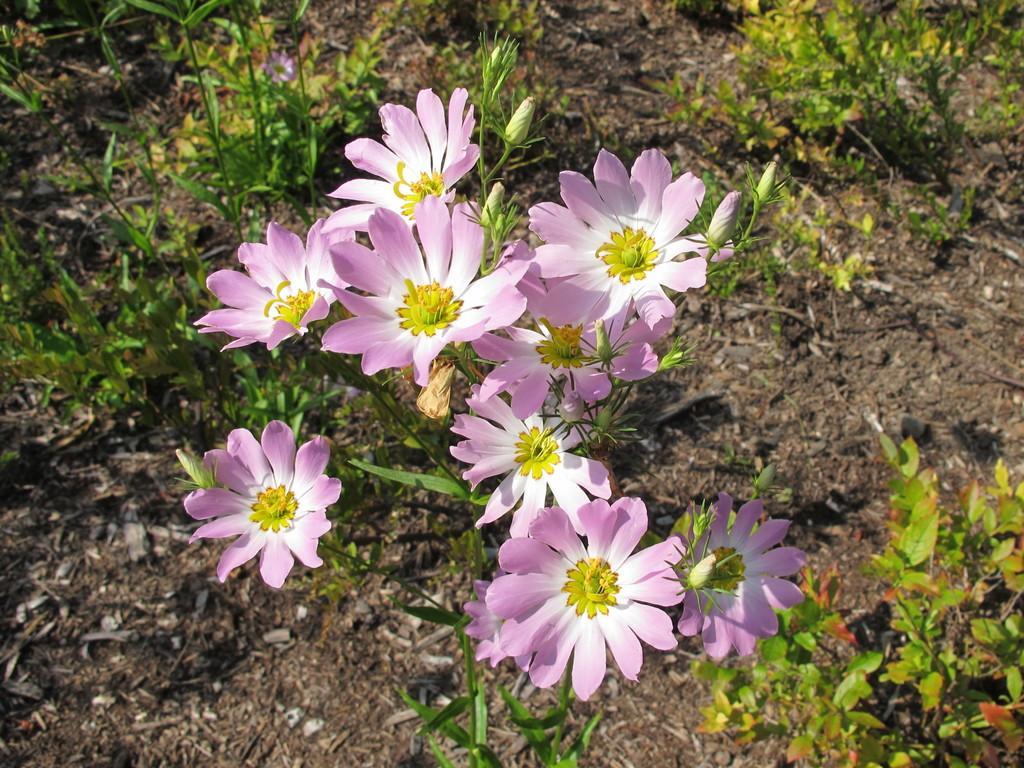Can you describe this image briefly? This image is taken outdoors. At the bottom of the image there is a ground with grass and a few plants on it. In the middle of the image there is a plant with beautiful flowers. Those flowers are pink and white in colors. 